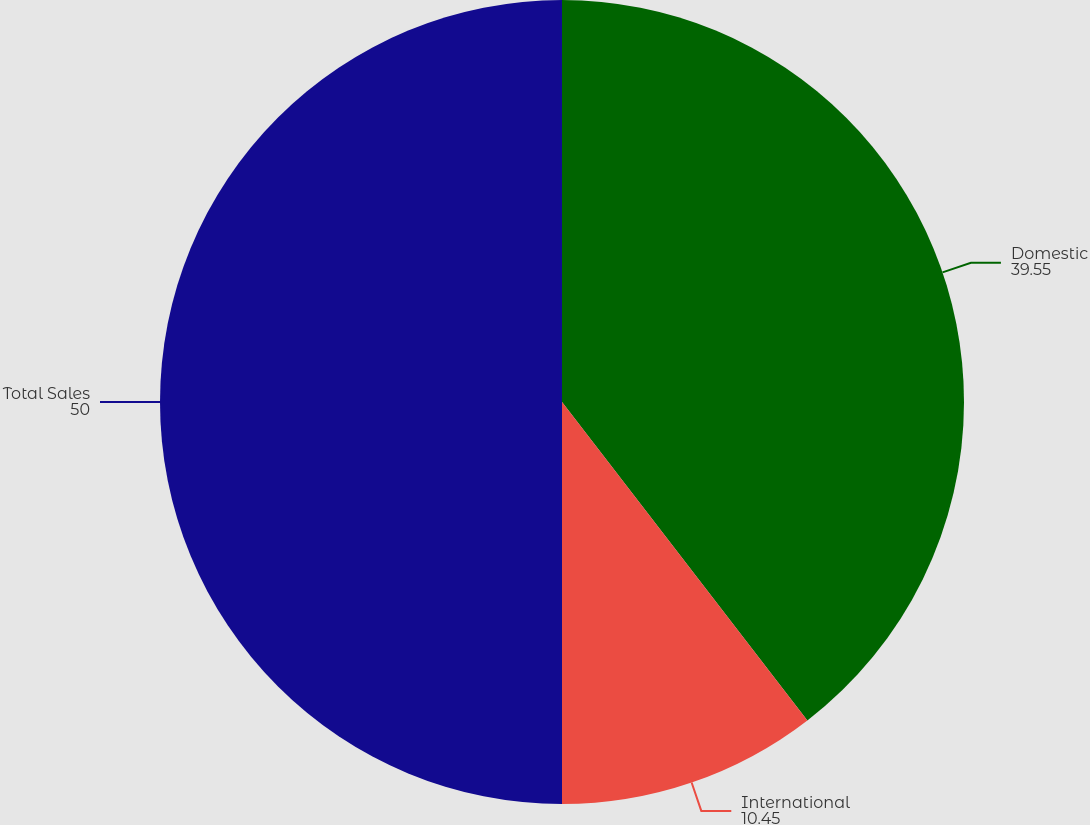Convert chart to OTSL. <chart><loc_0><loc_0><loc_500><loc_500><pie_chart><fcel>Domestic<fcel>International<fcel>Total Sales<nl><fcel>39.55%<fcel>10.45%<fcel>50.0%<nl></chart> 